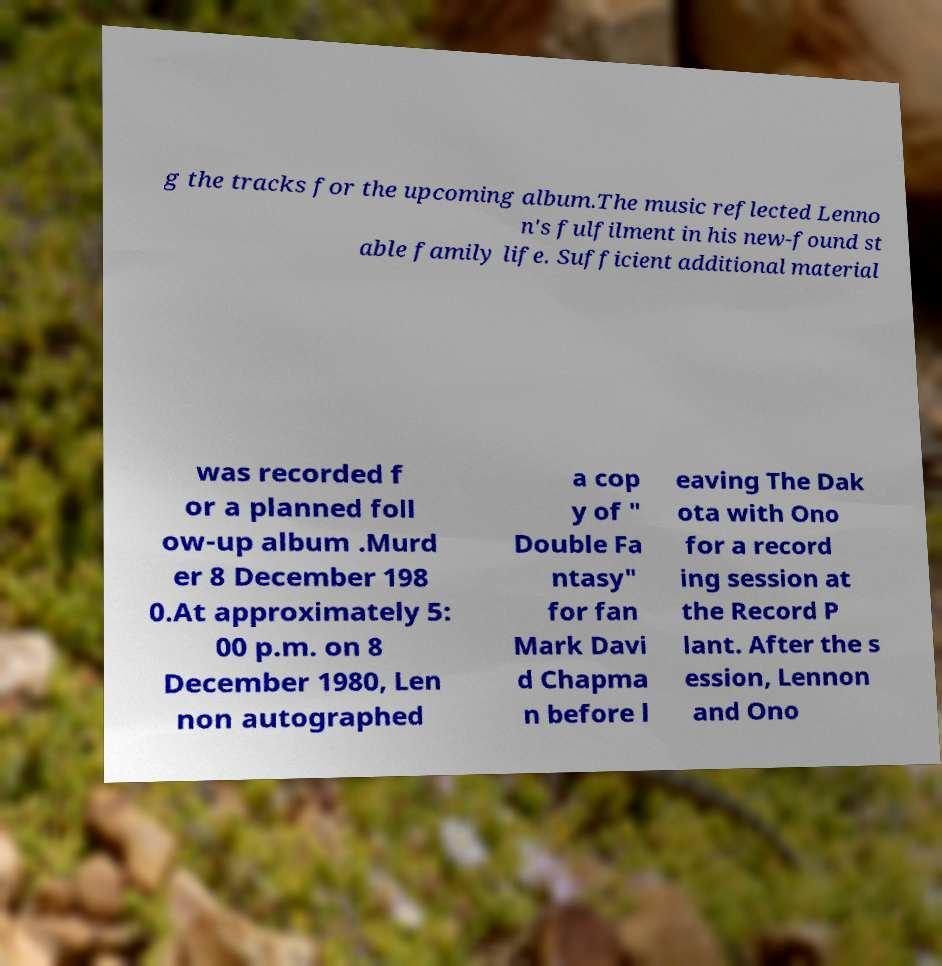Please identify and transcribe the text found in this image. g the tracks for the upcoming album.The music reflected Lenno n's fulfilment in his new-found st able family life. Sufficient additional material was recorded f or a planned foll ow-up album .Murd er 8 December 198 0.At approximately 5: 00 p.m. on 8 December 1980, Len non autographed a cop y of " Double Fa ntasy" for fan Mark Davi d Chapma n before l eaving The Dak ota with Ono for a record ing session at the Record P lant. After the s ession, Lennon and Ono 